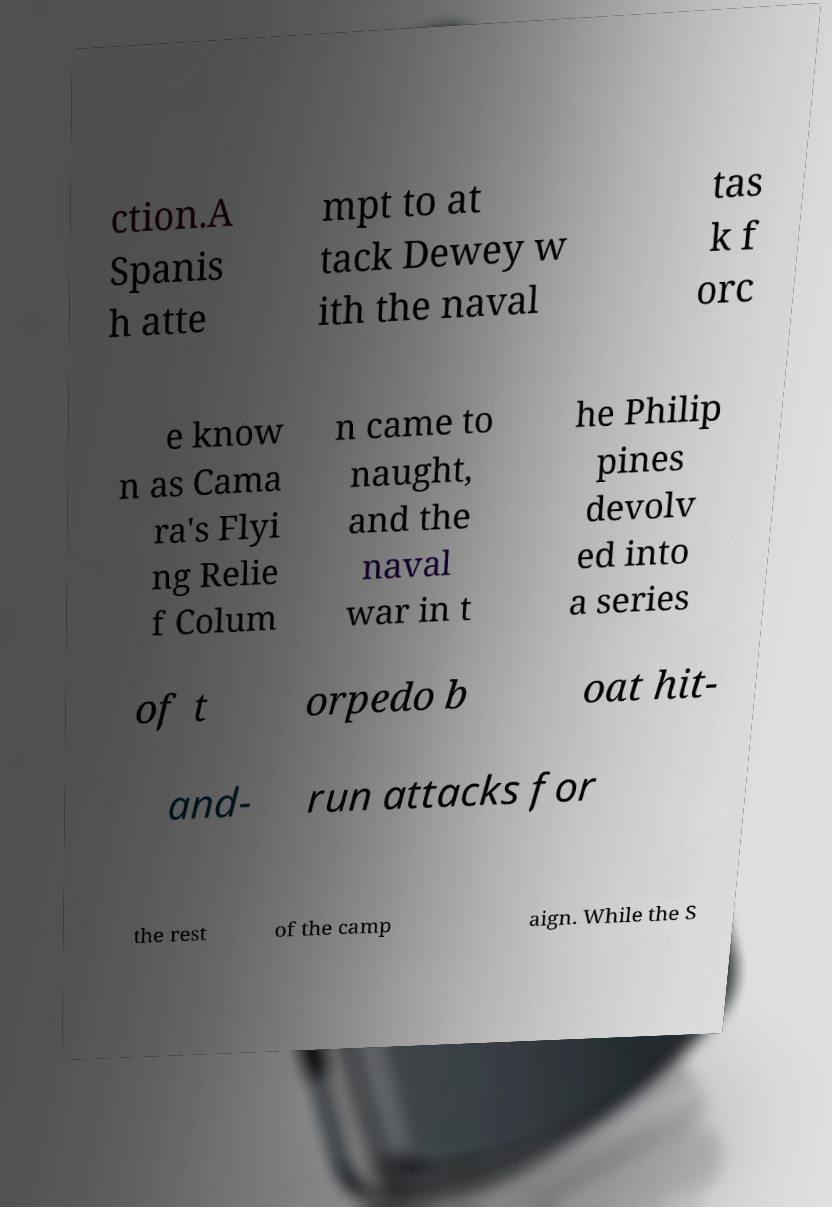I need the written content from this picture converted into text. Can you do that? ction.A Spanis h atte mpt to at tack Dewey w ith the naval tas k f orc e know n as Cama ra's Flyi ng Relie f Colum n came to naught, and the naval war in t he Philip pines devolv ed into a series of t orpedo b oat hit- and- run attacks for the rest of the camp aign. While the S 